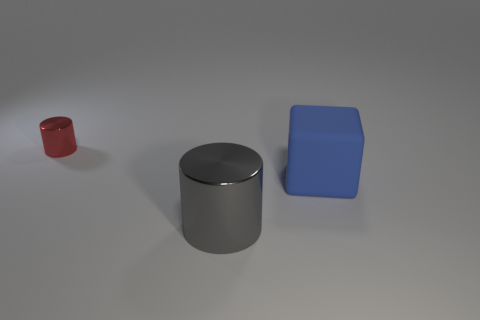There is a metallic object that is the same size as the blue cube; what color is it?
Offer a terse response. Gray. Is the number of metallic cylinders that are to the right of the large blue block the same as the number of yellow objects?
Give a very brief answer. Yes. What is the color of the metallic thing right of the metal cylinder behind the big matte block?
Your answer should be compact. Gray. What is the size of the thing that is in front of the thing on the right side of the big metallic object?
Provide a succinct answer. Large. What number of other objects are the same size as the red cylinder?
Provide a succinct answer. 0. The cylinder that is right of the object to the left of the thing in front of the large blue matte thing is what color?
Your response must be concise. Gray. What number of other things are there of the same shape as the small object?
Offer a terse response. 1. What shape is the metal thing behind the big block?
Keep it short and to the point. Cylinder. There is a small metallic object that is on the left side of the large metallic object; is there a red object behind it?
Provide a short and direct response. No. What is the color of the object that is in front of the tiny red thing and left of the big blue rubber cube?
Your response must be concise. Gray. 